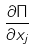<formula> <loc_0><loc_0><loc_500><loc_500>\frac { \partial \Pi } { \partial x _ { j } }</formula> 